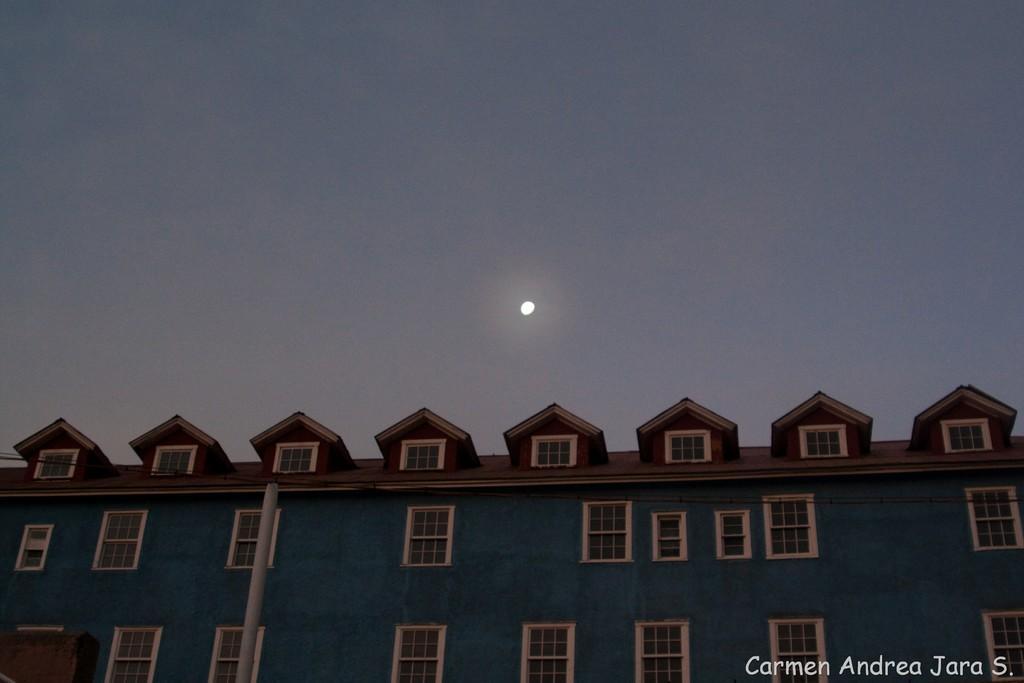Can you describe this image briefly? At the bottom of the picture, we see a building which is blue in color. We even see windows, door and a pole. At the top of the picture, we see the sky and the moon. 